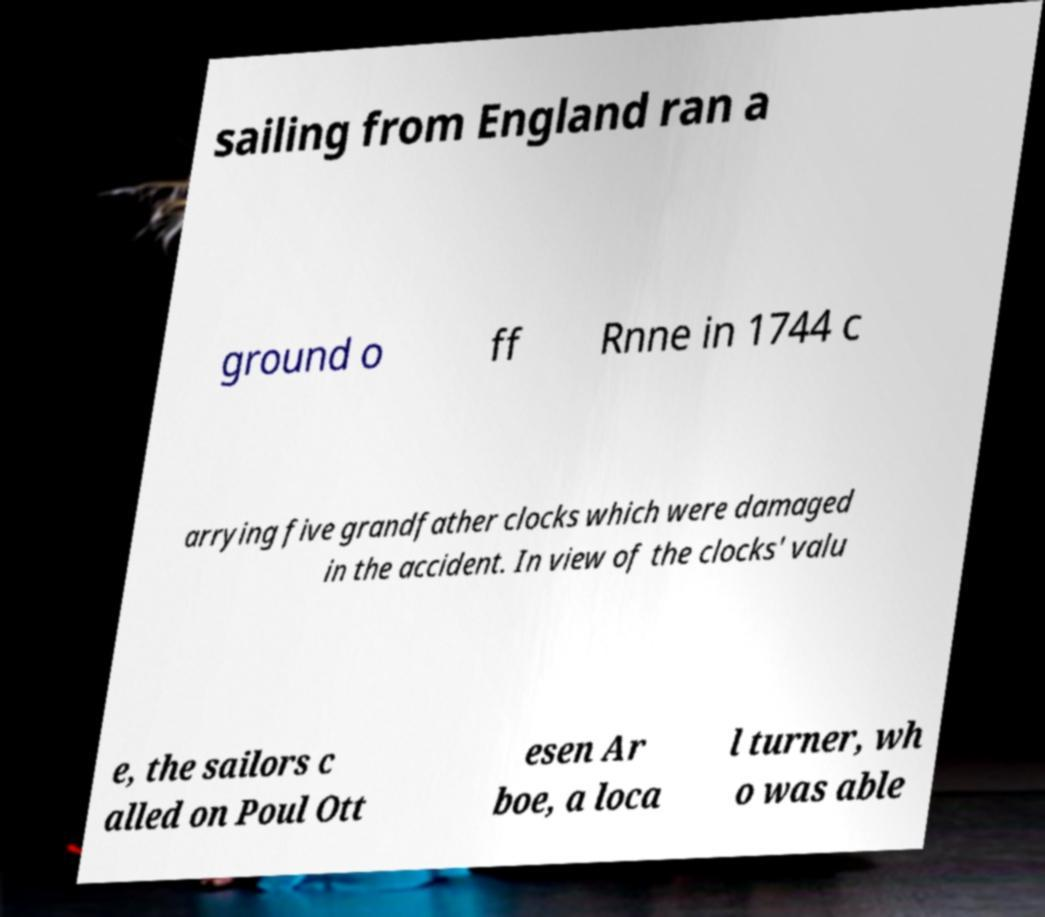For documentation purposes, I need the text within this image transcribed. Could you provide that? sailing from England ran a ground o ff Rnne in 1744 c arrying five grandfather clocks which were damaged in the accident. In view of the clocks' valu e, the sailors c alled on Poul Ott esen Ar boe, a loca l turner, wh o was able 